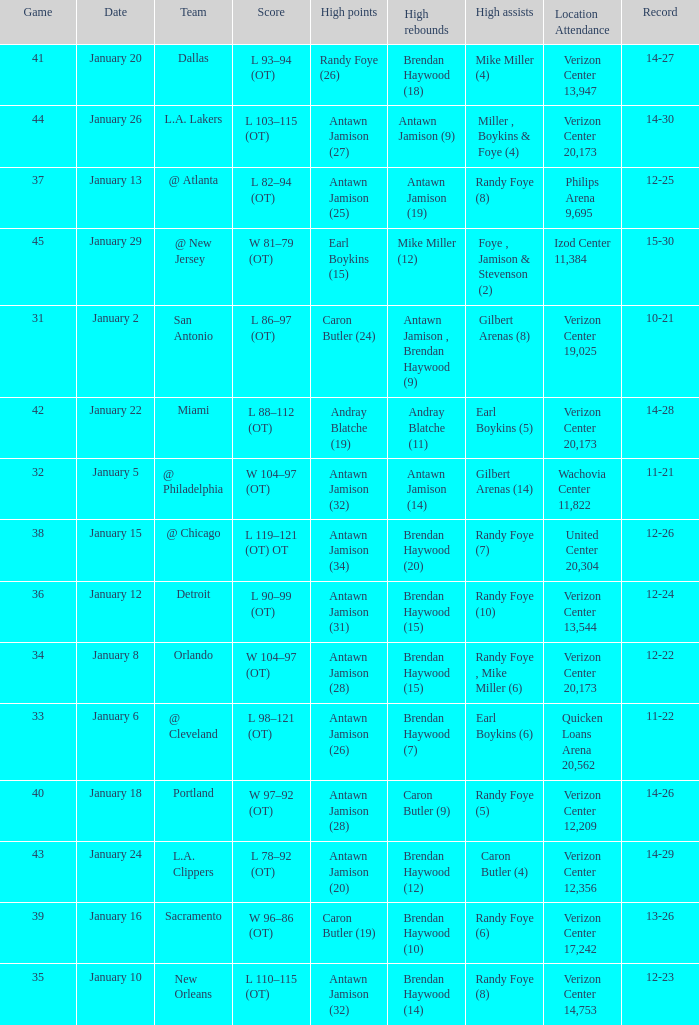Who had the highest points on January 2? Caron Butler (24). 